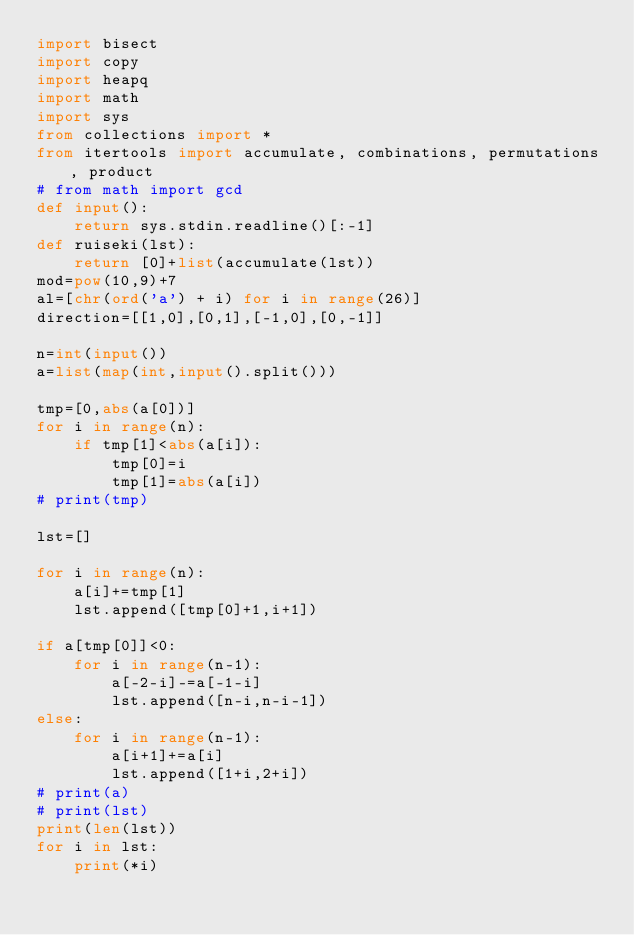<code> <loc_0><loc_0><loc_500><loc_500><_Python_>import bisect
import copy
import heapq
import math
import sys
from collections import *
from itertools import accumulate, combinations, permutations, product
# from math import gcd
def input():
    return sys.stdin.readline()[:-1]
def ruiseki(lst):
    return [0]+list(accumulate(lst))
mod=pow(10,9)+7
al=[chr(ord('a') + i) for i in range(26)]
direction=[[1,0],[0,1],[-1,0],[0,-1]]

n=int(input())
a=list(map(int,input().split()))

tmp=[0,abs(a[0])]
for i in range(n):
    if tmp[1]<abs(a[i]):
        tmp[0]=i
        tmp[1]=abs(a[i])
# print(tmp)

lst=[]

for i in range(n):
    a[i]+=tmp[1]
    lst.append([tmp[0]+1,i+1])

if a[tmp[0]]<0:
    for i in range(n-1):
        a[-2-i]-=a[-1-i]
        lst.append([n-i,n-i-1])
else:
    for i in range(n-1):
        a[i+1]+=a[i]
        lst.append([1+i,2+i])
# print(a)
# print(lst)
print(len(lst))
for i in lst:
    print(*i)</code> 